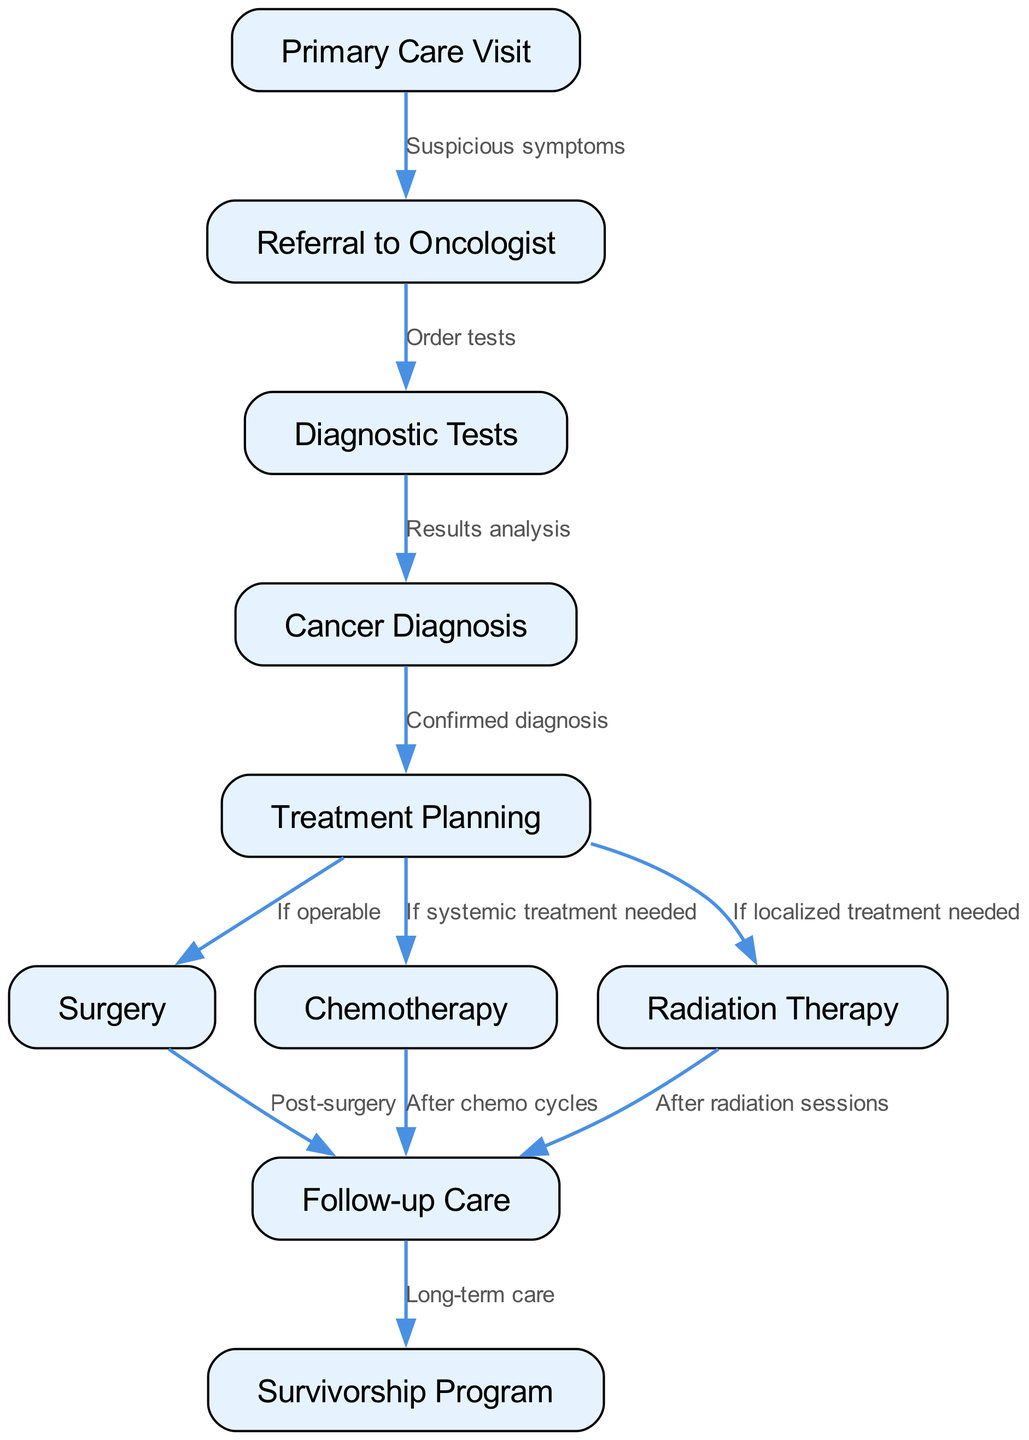What is the first step in the patient journey? The diagram starts with the "Primary Care Visit" node, which represents the initial consultation a patient has regarding their symptoms. This is the entry point into the cancer journey.
Answer: Primary Care Visit How many treatment options are indicated in the diagram? There are three treatment options represented: "Surgery," "Chemotherapy," and "Radiation Therapy." Each branch from the "Treatment Planning" node leads to one of these options.
Answer: 3 What follows a confirmed cancer diagnosis? After the "Cancer Diagnosis" node, the next step is "Treatment Planning," indicating that plans are made to address the patient's specific treatment needs following a diagnosis.
Answer: Treatment Planning If a patient receives chemotherapy, what is the next step? The diagram shows that after the "Chemotherapy" node, the patient goes to "Follow-up Care," suggesting that post-treatment care is provided after chemotherapy cycles are completed.
Answer: Follow-up Care What connects "Diagnostic Tests" to "Cancer Diagnosis"? There is an edge labeled "Results analysis" that connects "Diagnostic Tests" to "Cancer Diagnosis," indicating that the analysis of test results leads to the confirmation or denial of a cancer diagnosis.
Answer: Results analysis What are the long-term care options after "Follow-up Care"? According to the diagram, the "Survivorship Program" follows "Follow-up Care," emphasizing that there is a structured program for long-term health management after initial cancer treatment.
Answer: Survivorship Program What condition leads to surgery in the treatment planning stage? The edge from "Treatment Planning" to "Surgery" is labeled "If operable," suggesting that the decision for surgery depends on whether the cancer is operable or not.
Answer: If operable How many edges are there in the diagram? By counting, there are ten edges that represent the relationships and transitions between each of the nodes in the patient journey.
Answer: 10 What is the last node in the patient journey? The final step is the "Survivorship Program," which indicates that after the follow-up care, patients are supported through a program focused on long-term survivorship and wellness.
Answer: Survivorship Program 